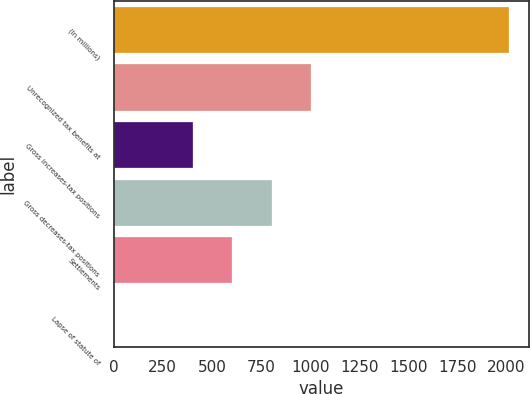Convert chart to OTSL. <chart><loc_0><loc_0><loc_500><loc_500><bar_chart><fcel>(In millions)<fcel>Unrecognized tax benefits at<fcel>Gross increases-tax positions<fcel>Gross decreases-tax positions<fcel>Settlements<fcel>Lapse of statute of<nl><fcel>2012<fcel>1006.05<fcel>402.48<fcel>804.86<fcel>603.67<fcel>0.1<nl></chart> 